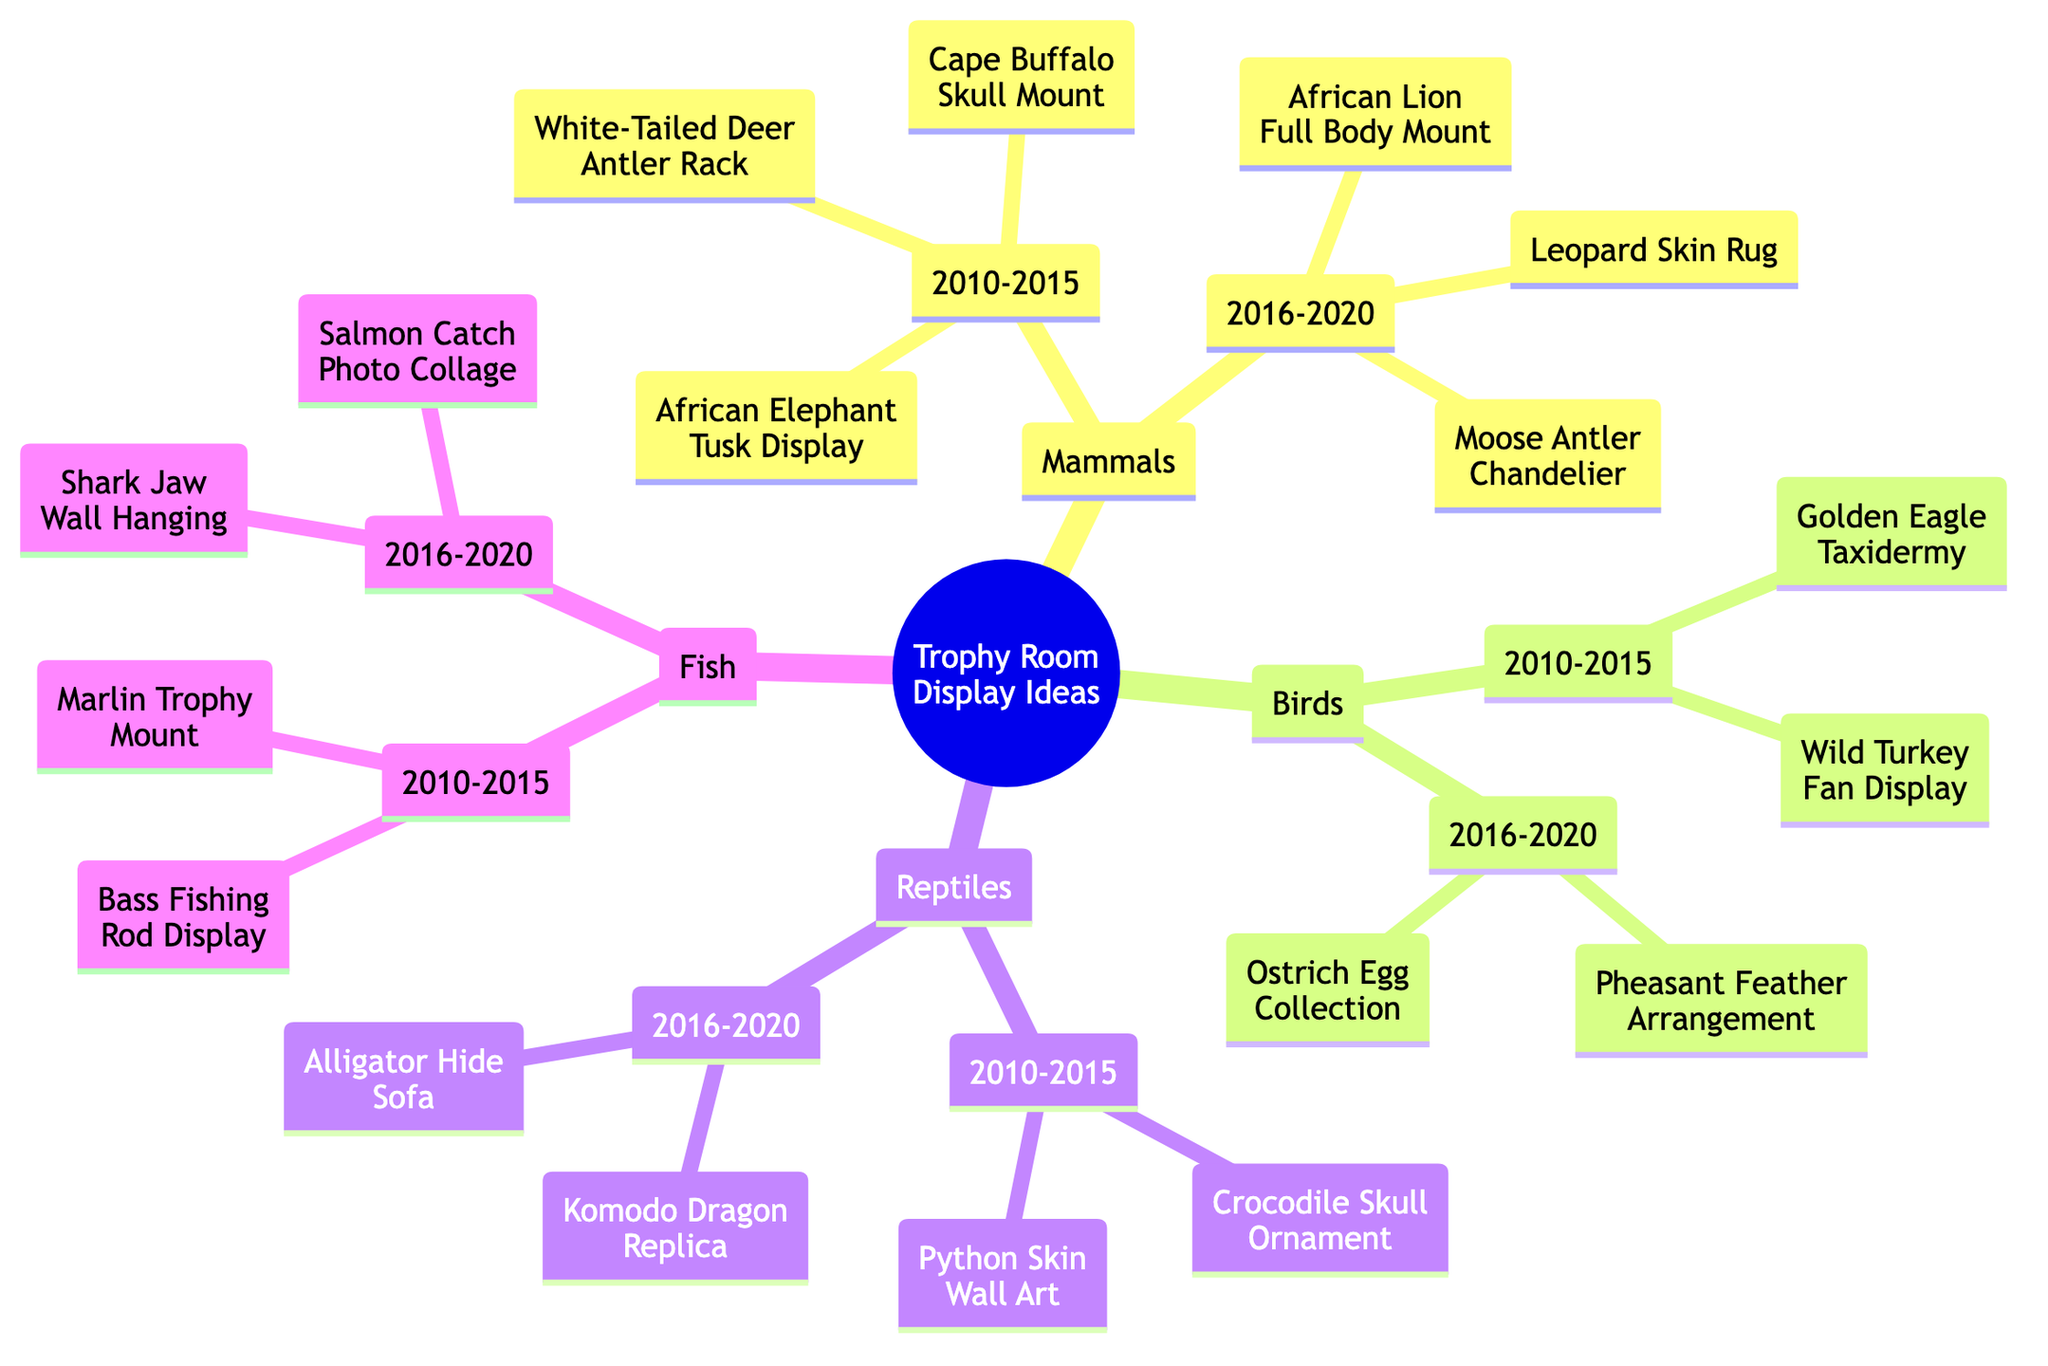What are the trophy display ideas for mammals acquired between 2010 and 2015? To find the trophy display ideas for mammals in that time frame, I look under the Mammals category and then check the list under 2010-2015. The items listed are "African Elephant Tusk Display," "Cape Buffalo Skull Mount," and "White-Tailed Deer Antler Rack."
Answer: African Elephant Tusk Display, Cape Buffalo Skull Mount, White-Tailed Deer Antler Rack How many different types of animals are represented in the trophy display ideas? The diagram categorizes the trophy display ideas into four types of animals: Mammals, Birds, Reptiles, and Fish. Counting these gives a total of four distinct types.
Answer: 4 Which display idea is listed under reptiles for the year 2016 to 2020? I need to look under the Reptiles category and find the list for the years 2016-2020. The items listed are "Komodo Dragon Replica" and "Alligator Hide Sofa." Selecting one, I can name either display as the answer.
Answer: Komodo Dragon Replica Are there more display ideas listed for fish acquired in 2010 to 2015 or for birds acquired in the same timeframe? First, I check the list under Fish for 2010-2015, which shows two items: "Marlin Trophy Mount" and "Bass Fishing Rod Display." Then, I check the Birds category, where I find two items: "Golden Eagle Taxidermy" and "Wild Turkey Fan Display." Since both categories have the same number of items listed (two), the answer confirms equality.
Answer: Equal What is the display item consisting of a furniture piece from the reptiles category? In the Reptiles section, I need to locate a display item that resembles furniture. Targeting the years 2016-2020, I find "Alligator Hide Sofa." This matches the description as it is a furniture piece.
Answer: Alligator Hide Sofa How many total trophy display ideas are there for fish acquired between 2016 and 2020? To determine this, I focus on the Fish category for the years 2016-2020, which lists two items: "Shark Jaw Wall Hanging" and "Salmon Catch Photo Collage." Counting these gives a total of two ideas for that time period.
Answer: 2 What are the display ideas for birds acquired from 2016 to 2020? I navigate to the Birds category and look under the 2016-2020 list. The two display ideas listed are "Pheasant Feather Arrangement" and "Ostrich Egg Collection." Thus, these are the ideas from that timeframe.
Answer: Pheasant Feather Arrangement, Ostrich Egg Collection Which animal category has the most display ideas from 2010 to 2015? By examining the diagram, I find that the Mammals category has three display ideas listed: "African Elephant Tusk Display," "Cape Buffalo Skull Mount," and "White-Tailed Deer Antler Rack." The Birds category also has two ideas, Reptiles list two, and Fish lists two. Thus, Mammals is the category with the most ideas in that timeframe.
Answer: Mammals 